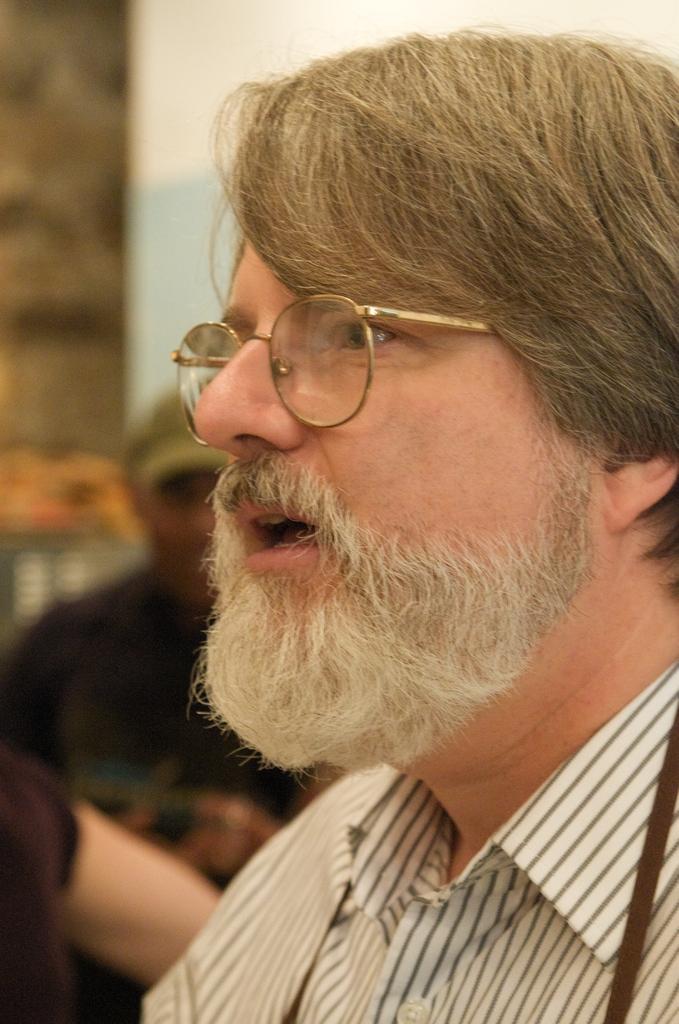Can you describe this image briefly? In the picture,there is a man he is having a beard and he is wearing spectacles,he is speaking something and the background of the man is blur. 